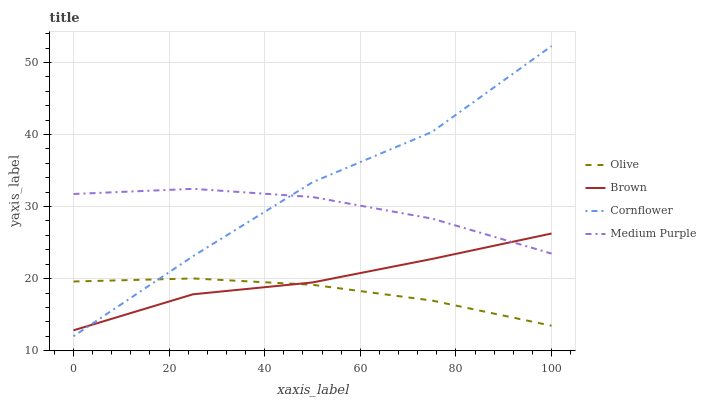Does Olive have the minimum area under the curve?
Answer yes or no. Yes. Does Cornflower have the maximum area under the curve?
Answer yes or no. Yes. Does Brown have the minimum area under the curve?
Answer yes or no. No. Does Brown have the maximum area under the curve?
Answer yes or no. No. Is Olive the smoothest?
Answer yes or no. Yes. Is Cornflower the roughest?
Answer yes or no. Yes. Is Brown the smoothest?
Answer yes or no. No. Is Brown the roughest?
Answer yes or no. No. Does Cornflower have the lowest value?
Answer yes or no. Yes. Does Brown have the lowest value?
Answer yes or no. No. Does Cornflower have the highest value?
Answer yes or no. Yes. Does Brown have the highest value?
Answer yes or no. No. Is Olive less than Medium Purple?
Answer yes or no. Yes. Is Medium Purple greater than Olive?
Answer yes or no. Yes. Does Olive intersect Brown?
Answer yes or no. Yes. Is Olive less than Brown?
Answer yes or no. No. Is Olive greater than Brown?
Answer yes or no. No. Does Olive intersect Medium Purple?
Answer yes or no. No. 